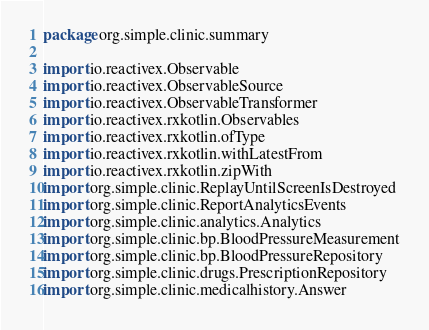<code> <loc_0><loc_0><loc_500><loc_500><_Kotlin_>package org.simple.clinic.summary

import io.reactivex.Observable
import io.reactivex.ObservableSource
import io.reactivex.ObservableTransformer
import io.reactivex.rxkotlin.Observables
import io.reactivex.rxkotlin.ofType
import io.reactivex.rxkotlin.withLatestFrom
import io.reactivex.rxkotlin.zipWith
import org.simple.clinic.ReplayUntilScreenIsDestroyed
import org.simple.clinic.ReportAnalyticsEvents
import org.simple.clinic.analytics.Analytics
import org.simple.clinic.bp.BloodPressureMeasurement
import org.simple.clinic.bp.BloodPressureRepository
import org.simple.clinic.drugs.PrescriptionRepository
import org.simple.clinic.medicalhistory.Answer</code> 